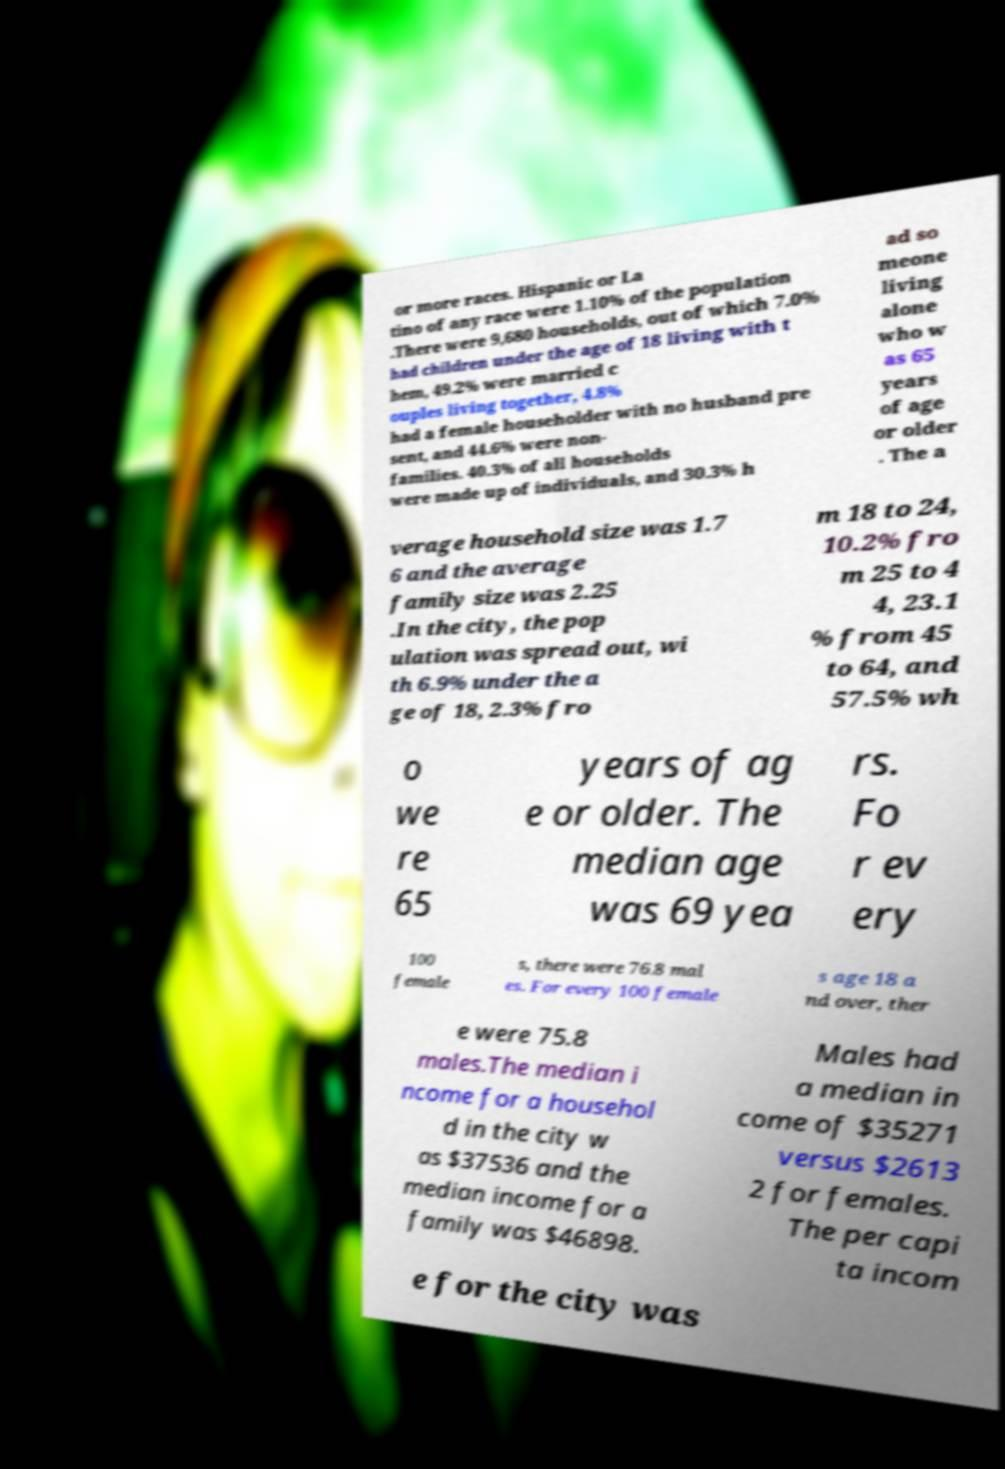Can you accurately transcribe the text from the provided image for me? or more races. Hispanic or La tino of any race were 1.10% of the population .There were 9,680 households, out of which 7.0% had children under the age of 18 living with t hem, 49.2% were married c ouples living together, 4.8% had a female householder with no husband pre sent, and 44.6% were non- families. 40.3% of all households were made up of individuals, and 30.3% h ad so meone living alone who w as 65 years of age or older . The a verage household size was 1.7 6 and the average family size was 2.25 .In the city, the pop ulation was spread out, wi th 6.9% under the a ge of 18, 2.3% fro m 18 to 24, 10.2% fro m 25 to 4 4, 23.1 % from 45 to 64, and 57.5% wh o we re 65 years of ag e or older. The median age was 69 yea rs. Fo r ev ery 100 female s, there were 76.8 mal es. For every 100 female s age 18 a nd over, ther e were 75.8 males.The median i ncome for a househol d in the city w as $37536 and the median income for a family was $46898. Males had a median in come of $35271 versus $2613 2 for females. The per capi ta incom e for the city was 